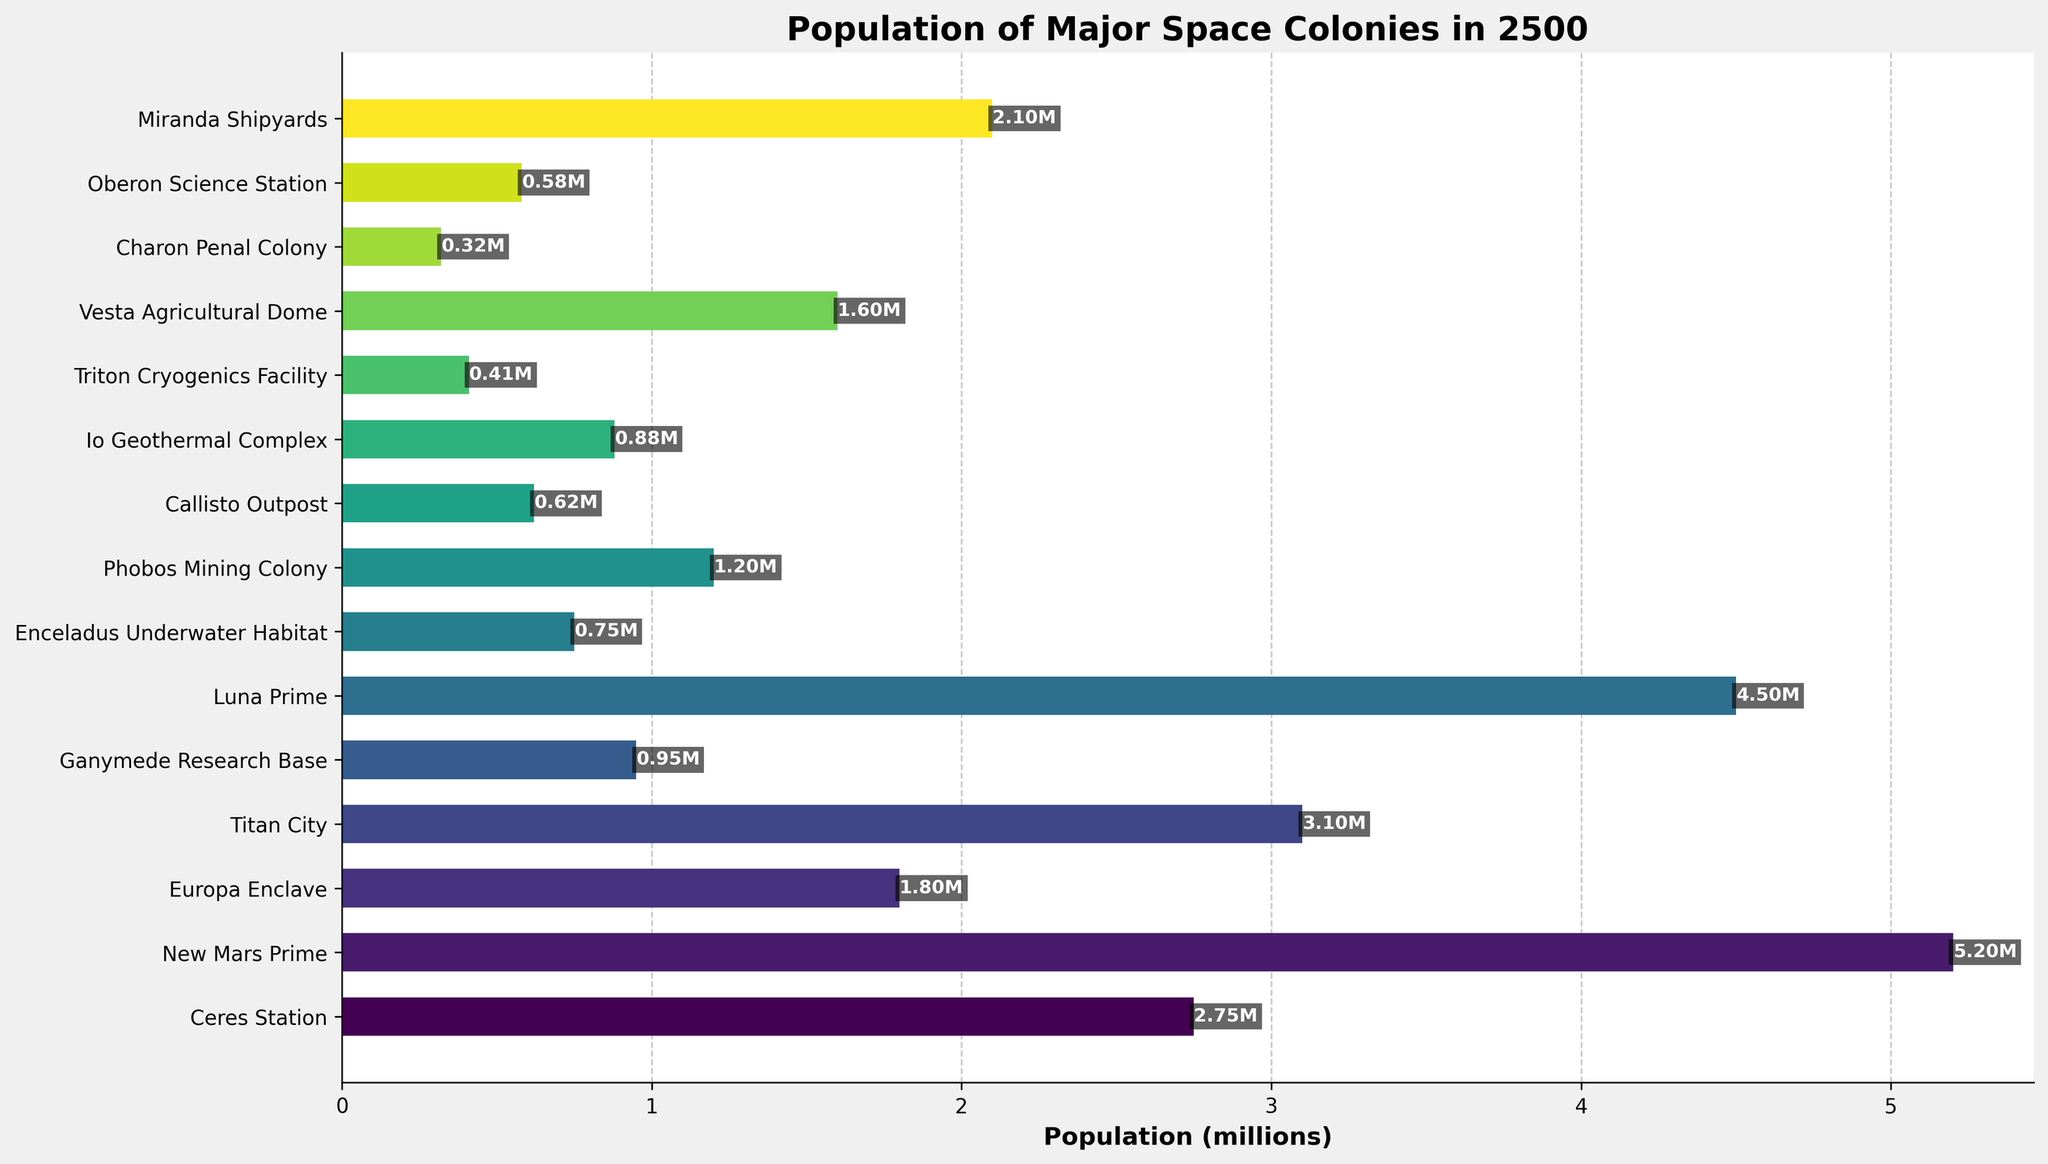What is the population of New Mars Prime? The label for New Mars Prime shows a population of 5.2 million.
Answer: 5.2 million Which colony has the lowest population? By observing the lengths of the bars, Charon Penal Colony has the shortest bar, indicating it has the lowest population. The population label confirms this.
Answer: Charon Penal Colony What is the total population of Titan City and Luna Prime combined? The population of Titan City is 3.1 million and Luna Prime is 4.5 million. Adding these together: 3.1 + 4.5 = 7.6 million.
Answer: 7.6 million How much greater is the population of New Mars Prime compared to Europa Enclave? The population of New Mars Prime is 5.2 million, and Europa Enclave is 1.8 million. Subtracting these: 5.2 - 1.8 = 3.4 million.
Answer: 3.4 million Which colonies have a population between 1 million and 2 million? The bars for Europa Enclave (1.8M), Phobos Mining Colony (1.2M), and Vesta Agricultural Dome (1.6M) fall within this range.
Answer: Europa Enclave, Phobos Mining Colony, Vesta Agricultural Dome Is the population of Titan City higher or lower than Miranda Shipyards? By comparing the bar lengths, Titan City's population (3.1M) is higher than Miranda Shipyards (2.1M).
Answer: Higher What is the average population of Ceres Station, Ganymede Research Base, and Enceladus Underwater Habitat? Sum the populations: 2.75M (Ceres Station) + 0.95M (Ganymede Research Base) + 0.75M (Enceladus Underwater Habitat) = 4.45M. Divide by 3: 4.45M / 3 = 1.483M.
Answer: 1.483 million How many colonies have a population greater than 3 million? Identify bars with lengths representing populations greater than 3 million: New Mars Prime (5.2M), Luna Prime (4.5M), and Titan City (3.1M).
Answer: 3 What is the difference in population between Io Geothermal Complex and Triton Cryogenics Facility? The population of Io Geothermal Complex is 0.88 million and Triton Cryogenics Facility is 0.41 million. Subtract these: 0.88 - 0.41 = 0.47 million.
Answer: 0.47 million 